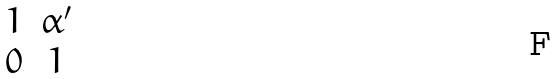<formula> <loc_0><loc_0><loc_500><loc_500>\begin{matrix} 1 & \alpha ^ { \prime } \\ 0 & 1 \end{matrix}</formula> 